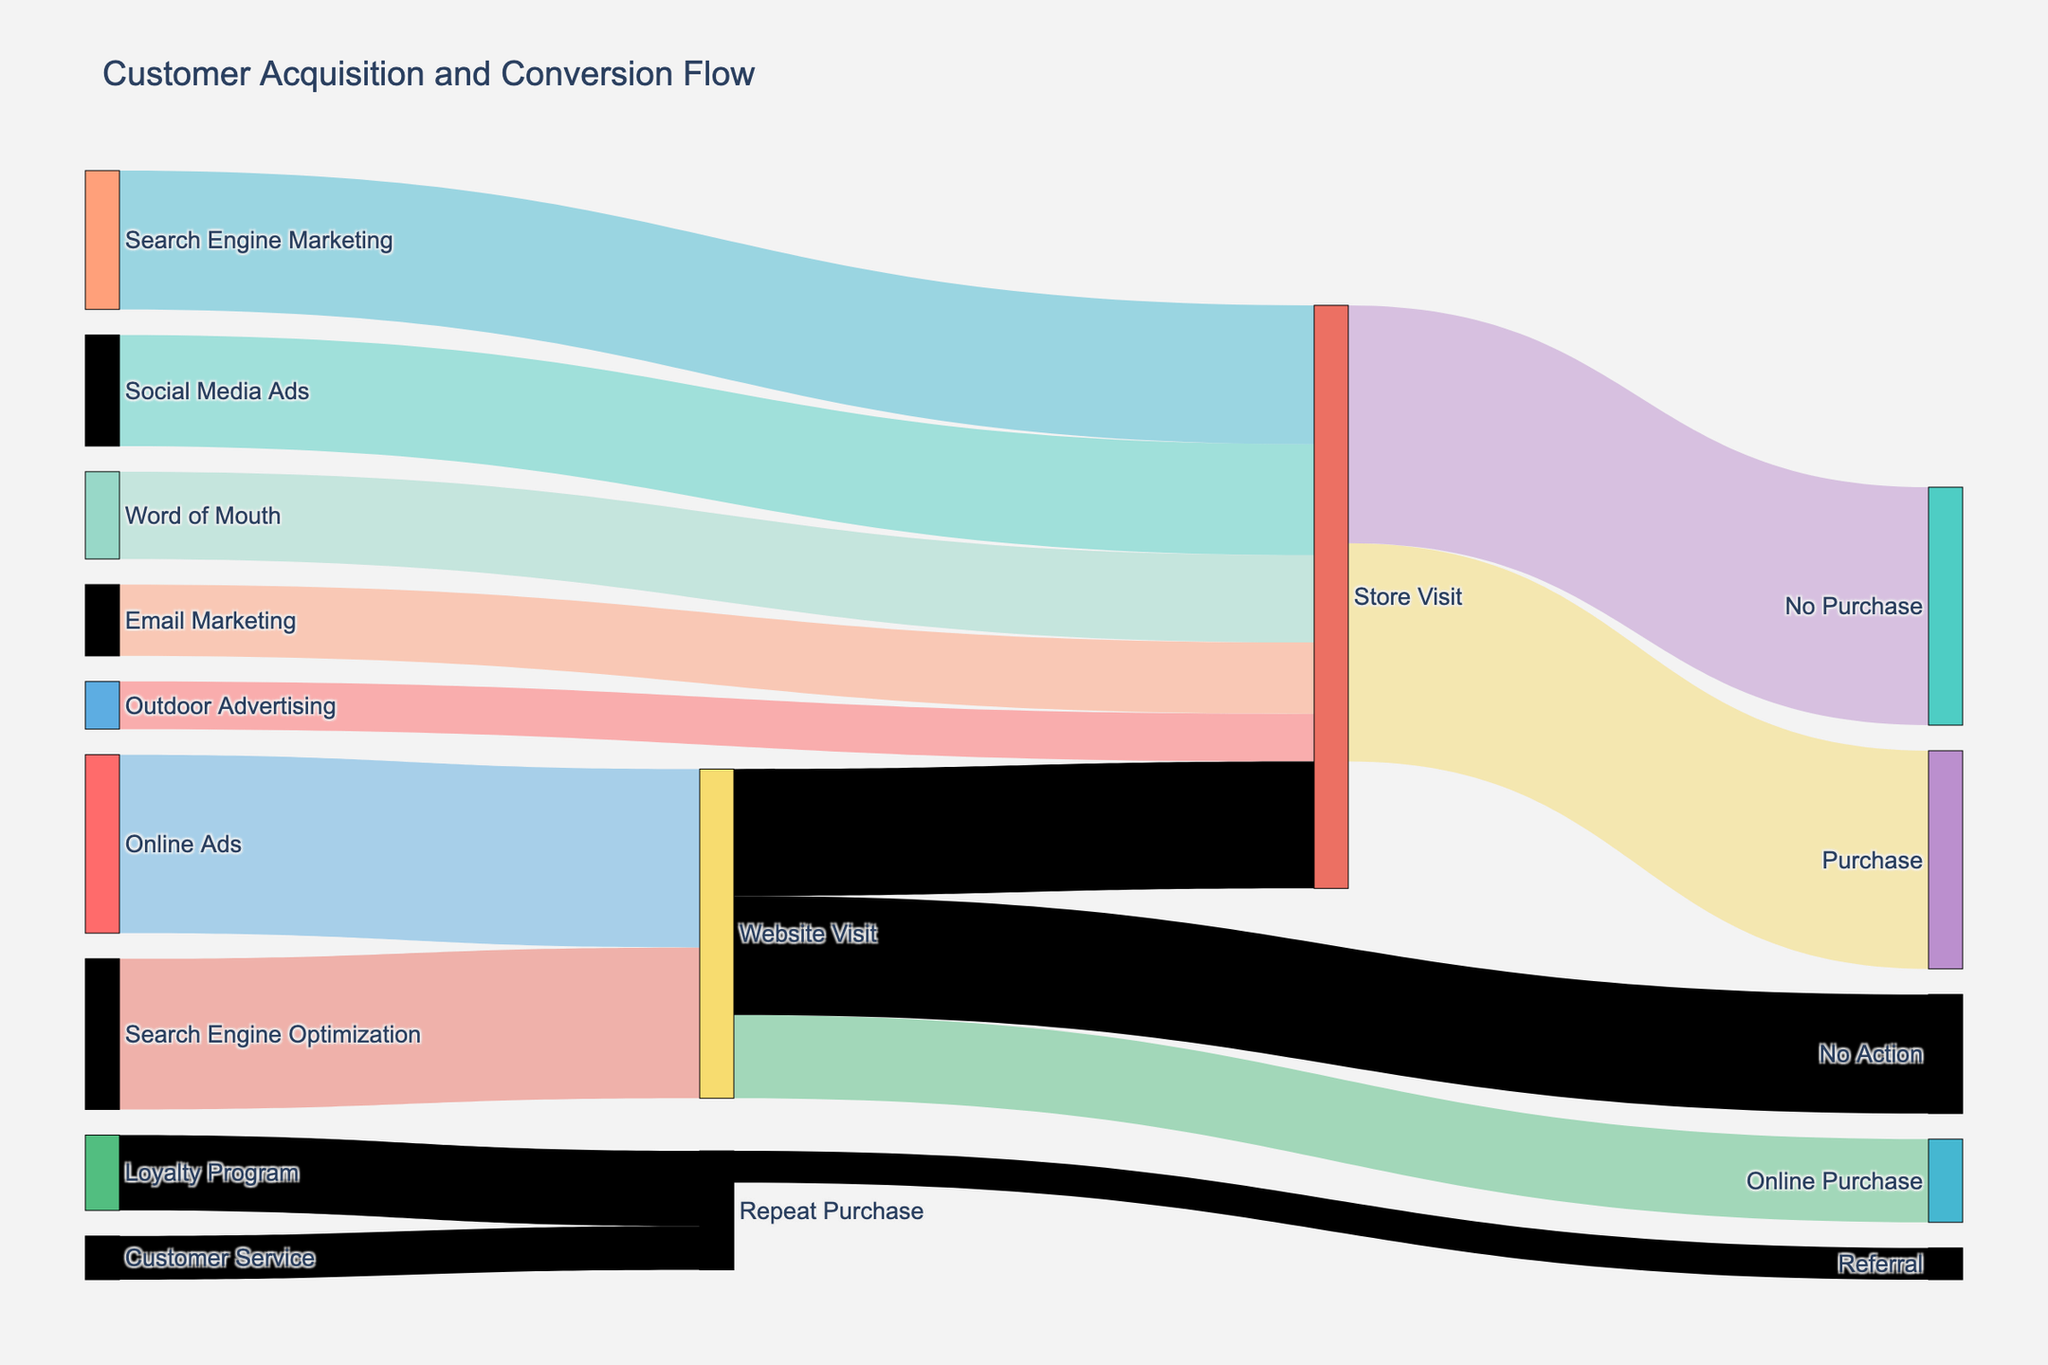What is the title of the figure? The title can be found at the top of the visual, which is typically designed to summarize the key topic or focus of the plot. In this case, it clearly states "Customer Acquisition and Conversion Flow"
Answer: Customer Acquisition and Conversion Flow How many customer acquisition channels are included in the diagram? To determine this, look at the number of unique sources listed before any target values. These sources represent the different customer acquisition channels.
Answer: 6 What is the largest source of store visits? Look at the thickness of the links connecting each acquisition channel to Store Visit; notice the labels and compare their values. The channel with the thickest link has the highest value.
Answer: Search Engine Marketing How many website visits do not result in any action? Identify the flow from Website Visit to No Action by looking at the link label. The value associated with this flow directly tells you the number of website visits that result in no action.
Answer: 3000 What percentage of store visits result in purchases? To find the percentage, use the values for Store Visit to Purchase and the total Store Visit. Divide the number of purchases by the total Store Visit and multiply by 100. 
(5500 / (5500 + 6000)) * 100 = 47.83%
Answer: 47.83% What is the combined total number of customers acquired through Outdoor Advertising and Email Marketing? Identify the values associated with Outdoor Advertising and Email Marketing leading to Store Visit. Adding these two values will give the combined total for these channels. 1200 (Outdoor Advertising) + 1800 (Email Marketing) = 3000
Answer: 3000 Which channel leads to more purchases: Website visits leading to Online Purchase or Store Visits leading to Purchase? Compare the values of the links from Website Visit to Online Purchase and Store Visit to Purchase. The one with the higher value has more purchases.
Answer: Store Visits leading to Purchase What is the total number of repeat purchases? Add the values of Loyalty Program to Repeat Purchase and Customer Service to Repeat Purchase, as both contribute to the total repeat purchases. 1900 (Loyalty Program) + 1100 (Customer Service) = 3000
Answer: 3000 What is the source with the smallest contribution to Store Visit? Identify all sources leading to Store Visit and compare their values. The source with the smallest value is the answer.
Answer: Outdoor Advertising How many people visit a store after initially visiting the website? Look for the flow from Website Visit to Store Visit and note the value of this link.
Answer: 3200 